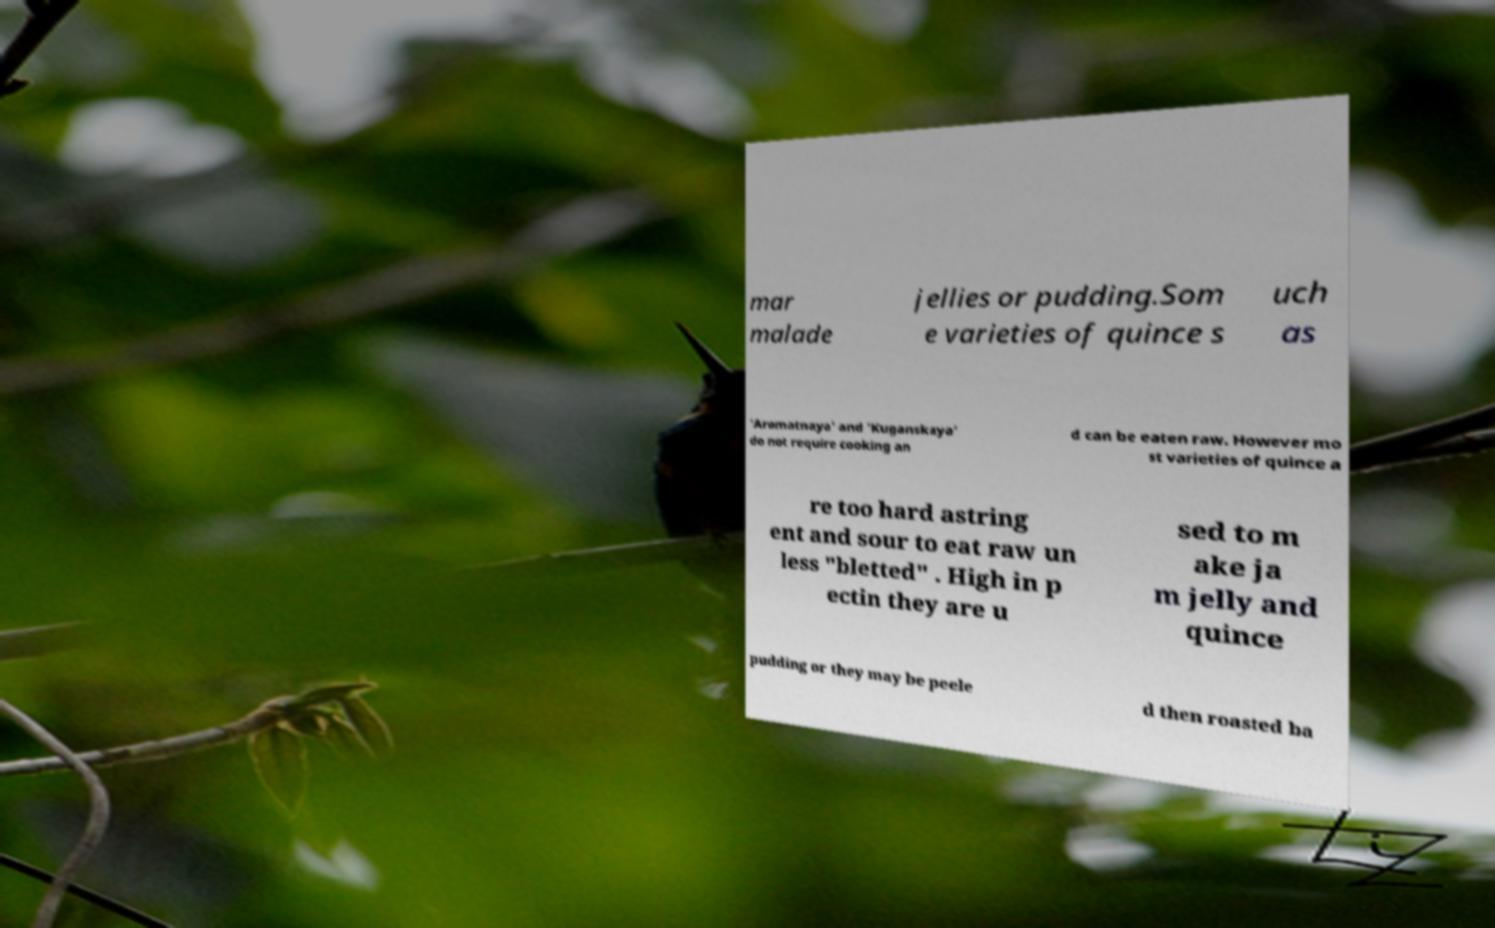I need the written content from this picture converted into text. Can you do that? mar malade jellies or pudding.Som e varieties of quince s uch as 'Aromatnaya' and 'Kuganskaya' do not require cooking an d can be eaten raw. However mo st varieties of quince a re too hard astring ent and sour to eat raw un less "bletted" . High in p ectin they are u sed to m ake ja m jelly and quince pudding or they may be peele d then roasted ba 